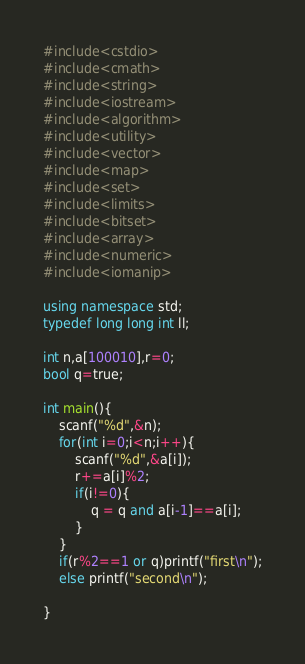Convert code to text. <code><loc_0><loc_0><loc_500><loc_500><_C++_>#include<cstdio>
#include<cmath>
#include<string>
#include<iostream>
#include<algorithm>
#include<utility>
#include<vector>
#include<map>
#include<set>
#include<limits>
#include<bitset>
#include<array>
#include<numeric>
#include<iomanip>
 
using namespace std;
typedef long long int ll;
 
int n,a[100010],r=0;
bool q=true;
 
int main(){
    scanf("%d",&n);
    for(int i=0;i<n;i++){
        scanf("%d",&a[i]);
        r+=a[i]%2;
        if(i!=0){
            q = q and a[i-1]==a[i];
        }
    }
    if(r%2==1 or q)printf("first\n");
    else printf("second\n");
    
}</code> 